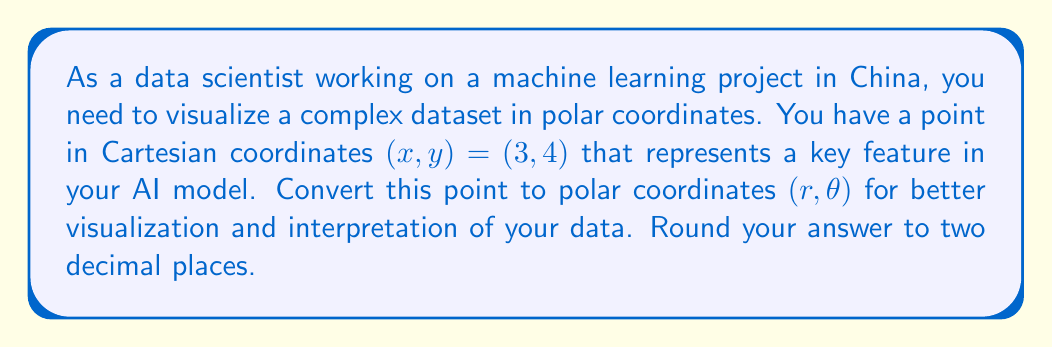Provide a solution to this math problem. To convert Cartesian coordinates $(x, y)$ to polar coordinates $(r, \theta)$, we use the following formulas:

1. For the radius $r$:
   $$r = \sqrt{x^2 + y^2}$$

2. For the angle $\theta$ (in radians):
   $$\theta = \arctan2(y, x)$$

Let's solve this step-by-step:

1. Calculate $r$:
   $$r = \sqrt{3^2 + 4^2} = \sqrt{9 + 16} = \sqrt{25} = 5$$

2. Calculate $\theta$:
   $$\theta = \arctan2(4, 3)$$
   
   Using a calculator or Python's math library, we get:
   $$\theta \approx 0.9272952180016122 \text{ radians}$$

3. Convert radians to degrees:
   $$\theta \text{ (in degrees)} = 0.9272952180016122 \times \frac{180}{\pi} \approx 53.13010235415598°$$

4. Rounding to two decimal places:
   $r = 5.00$
   $\theta \approx 53.13°$

[asy]
import geometry;

size(200);
defaultpen(fontsize(10pt));

pair O=(0,0), P=(3,4);
draw(O--P,Arrow);
draw(arc(O,5,0,53.13),Arrow);

dot("O",O,SW);
dot("P(3,4)",P,NE);

label("$r=5$", (1.5,2), E);
label("$\theta=53.13°$", (2.5,0.5), SE);

draw((-1,0)--(5,0),Arrow);
draw((0,-1)--(0,5),Arrow);

label("x", (5,0), E);
label("y", (0,5), N);
[/asy]
Answer: The point $(3, 4)$ in Cartesian coordinates is approximately $(5.00, 53.13°)$ in polar coordinates. 